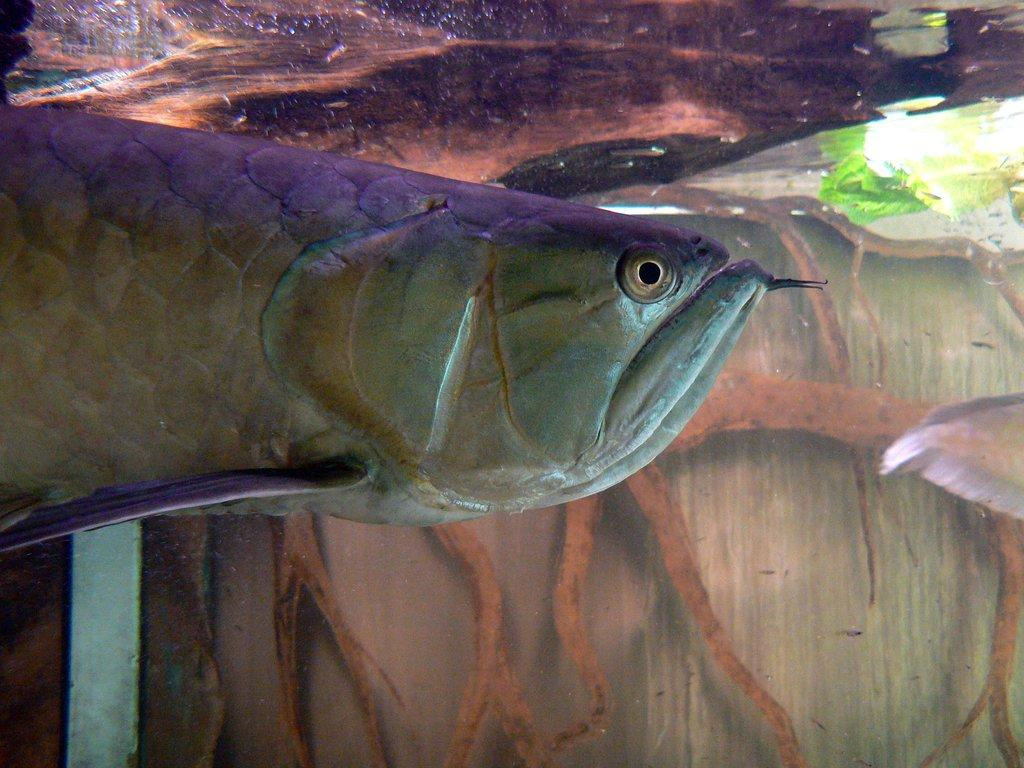What is in the water in the image? There is a fish in the water. What can be seen in the background of the image? There are roots, a leaf, and a platform visible in the background. Where is the playground located in the image? There is no playground present in the image. What type of fowl can be seen in the image? There are no birds or fowl visible in the image. 